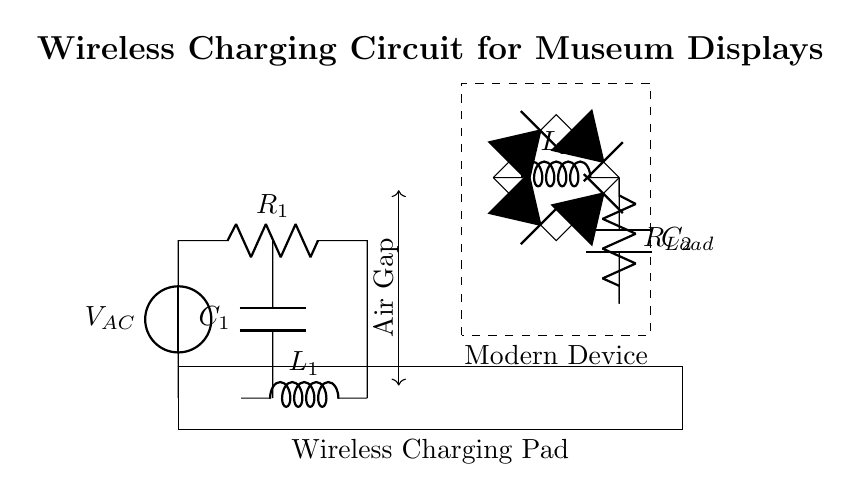What type of circuit is this? This is a wireless charging circuit designed specifically for modern devices, illustrated by the presence of coils and the charging pads shown.
Answer: wireless charging What does L1 represent in the circuit? L1 signifies the primary coil in the wireless charging pad, essential for creating the magnetic field necessary for energy transfer.
Answer: primary coil What is the purpose of C1 in the circuit? C1, the capacitor, is used for resonance, allowing the circuit to operate efficiently at its designated frequency for wireless power transmission.
Answer: resonance How many diodes are used in the rectifier section? There are four diodes used in the rectifier section, which are responsible for converting AC to DC in the device receiving the charge.
Answer: four What component is used to smooth the output voltage? The component used to smooth the output voltage in the circuit is C2, which acts as a smoothing capacitor.
Answer: smoothing capacitor What indicates the air gap in the circuit? The air gap is indicated by a double-headed arrow, showing the space between the primary and secondary coils where magnetic coupling occurs.
Answer: air gap What is the load represented by RLoad in the circuit? RLoad indicates the load resistor, which represents the modern device's resistance receiving energy from the wireless charging pad.
Answer: load resistor 